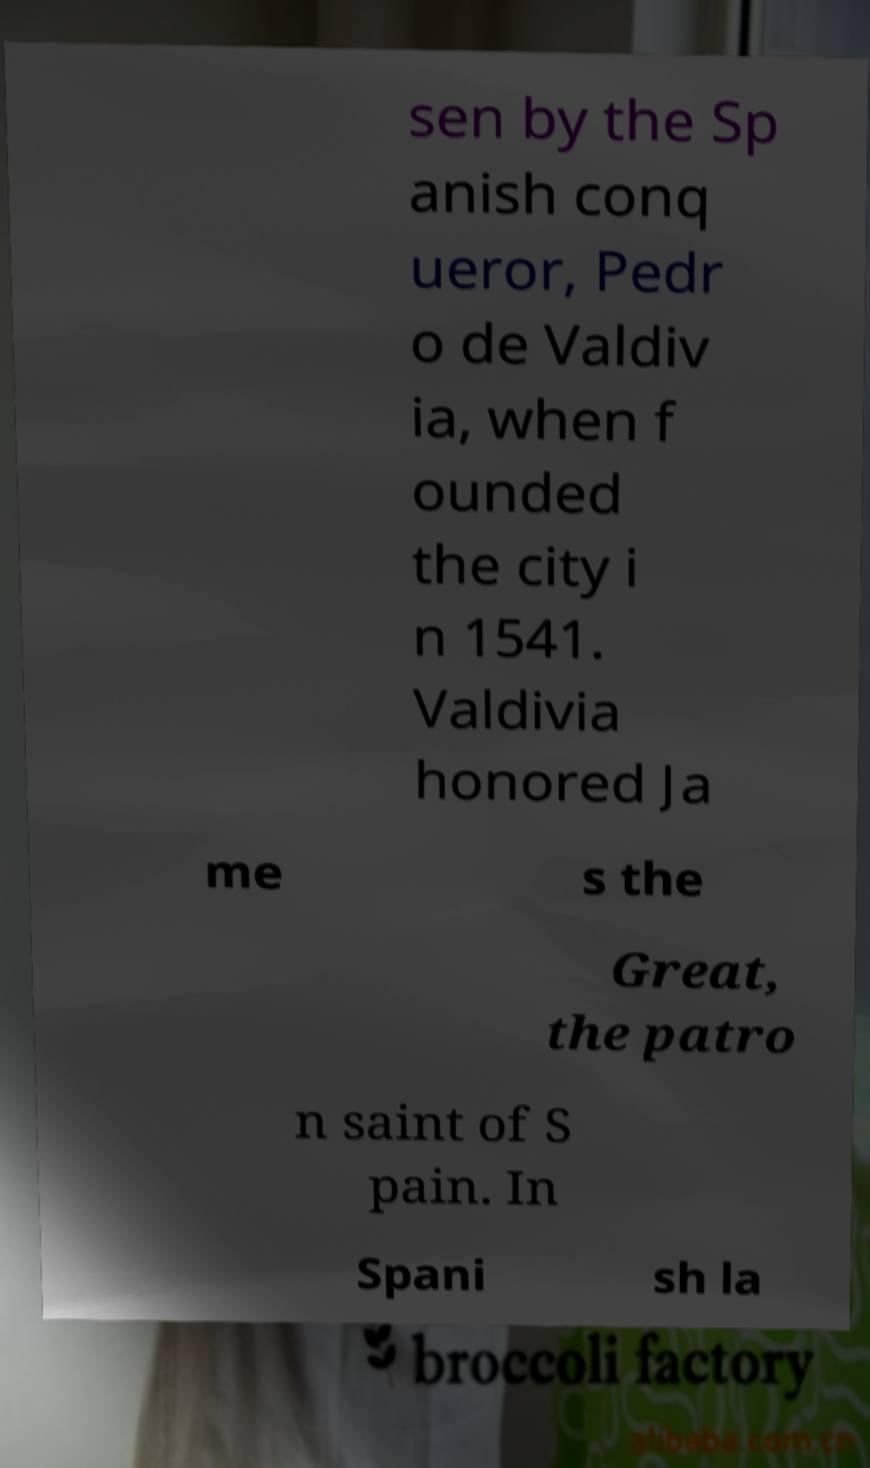Can you accurately transcribe the text from the provided image for me? sen by the Sp anish conq ueror, Pedr o de Valdiv ia, when f ounded the city i n 1541. Valdivia honored Ja me s the Great, the patro n saint of S pain. In Spani sh la 